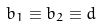<formula> <loc_0><loc_0><loc_500><loc_500>b _ { 1 } \equiv b _ { 2 } \equiv d</formula> 